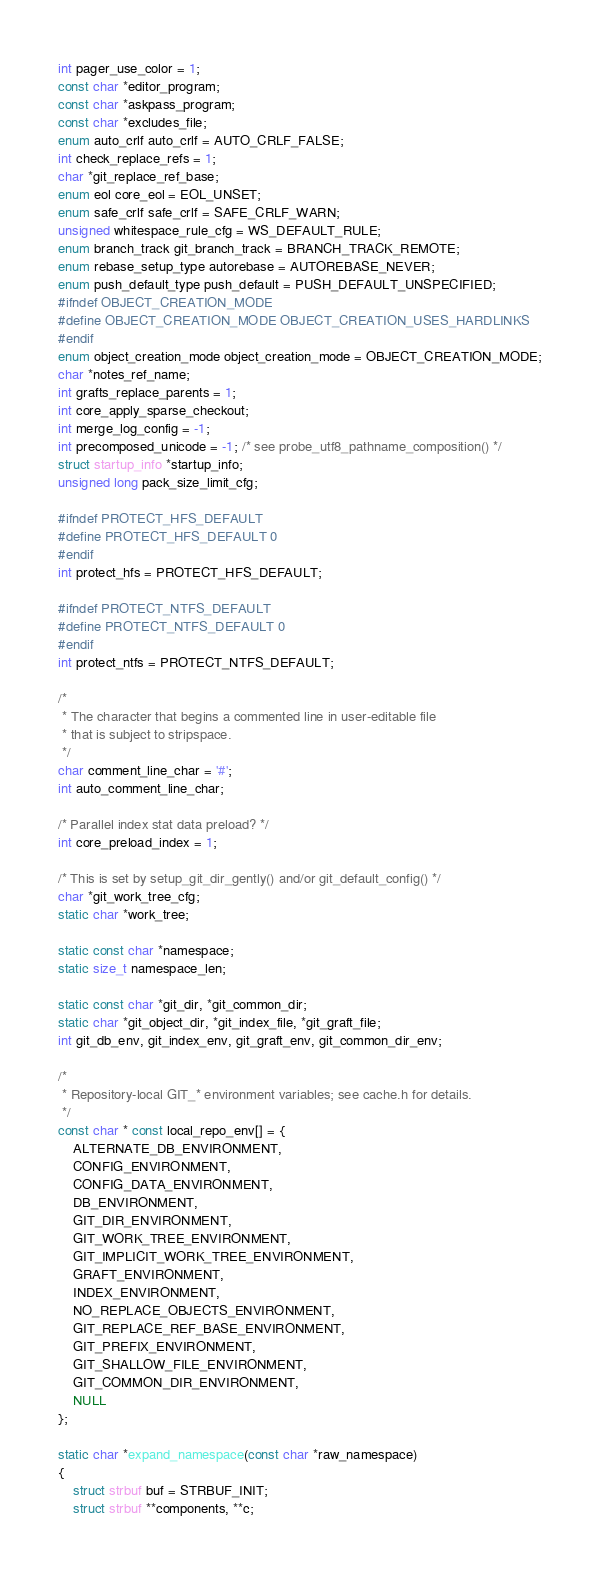<code> <loc_0><loc_0><loc_500><loc_500><_C_>int pager_use_color = 1;
const char *editor_program;
const char *askpass_program;
const char *excludes_file;
enum auto_crlf auto_crlf = AUTO_CRLF_FALSE;
int check_replace_refs = 1;
char *git_replace_ref_base;
enum eol core_eol = EOL_UNSET;
enum safe_crlf safe_crlf = SAFE_CRLF_WARN;
unsigned whitespace_rule_cfg = WS_DEFAULT_RULE;
enum branch_track git_branch_track = BRANCH_TRACK_REMOTE;
enum rebase_setup_type autorebase = AUTOREBASE_NEVER;
enum push_default_type push_default = PUSH_DEFAULT_UNSPECIFIED;
#ifndef OBJECT_CREATION_MODE
#define OBJECT_CREATION_MODE OBJECT_CREATION_USES_HARDLINKS
#endif
enum object_creation_mode object_creation_mode = OBJECT_CREATION_MODE;
char *notes_ref_name;
int grafts_replace_parents = 1;
int core_apply_sparse_checkout;
int merge_log_config = -1;
int precomposed_unicode = -1; /* see probe_utf8_pathname_composition() */
struct startup_info *startup_info;
unsigned long pack_size_limit_cfg;

#ifndef PROTECT_HFS_DEFAULT
#define PROTECT_HFS_DEFAULT 0
#endif
int protect_hfs = PROTECT_HFS_DEFAULT;

#ifndef PROTECT_NTFS_DEFAULT
#define PROTECT_NTFS_DEFAULT 0
#endif
int protect_ntfs = PROTECT_NTFS_DEFAULT;

/*
 * The character that begins a commented line in user-editable file
 * that is subject to stripspace.
 */
char comment_line_char = '#';
int auto_comment_line_char;

/* Parallel index stat data preload? */
int core_preload_index = 1;

/* This is set by setup_git_dir_gently() and/or git_default_config() */
char *git_work_tree_cfg;
static char *work_tree;

static const char *namespace;
static size_t namespace_len;

static const char *git_dir, *git_common_dir;
static char *git_object_dir, *git_index_file, *git_graft_file;
int git_db_env, git_index_env, git_graft_env, git_common_dir_env;

/*
 * Repository-local GIT_* environment variables; see cache.h for details.
 */
const char * const local_repo_env[] = {
	ALTERNATE_DB_ENVIRONMENT,
	CONFIG_ENVIRONMENT,
	CONFIG_DATA_ENVIRONMENT,
	DB_ENVIRONMENT,
	GIT_DIR_ENVIRONMENT,
	GIT_WORK_TREE_ENVIRONMENT,
	GIT_IMPLICIT_WORK_TREE_ENVIRONMENT,
	GRAFT_ENVIRONMENT,
	INDEX_ENVIRONMENT,
	NO_REPLACE_OBJECTS_ENVIRONMENT,
	GIT_REPLACE_REF_BASE_ENVIRONMENT,
	GIT_PREFIX_ENVIRONMENT,
	GIT_SHALLOW_FILE_ENVIRONMENT,
	GIT_COMMON_DIR_ENVIRONMENT,
	NULL
};

static char *expand_namespace(const char *raw_namespace)
{
	struct strbuf buf = STRBUF_INIT;
	struct strbuf **components, **c;
</code> 